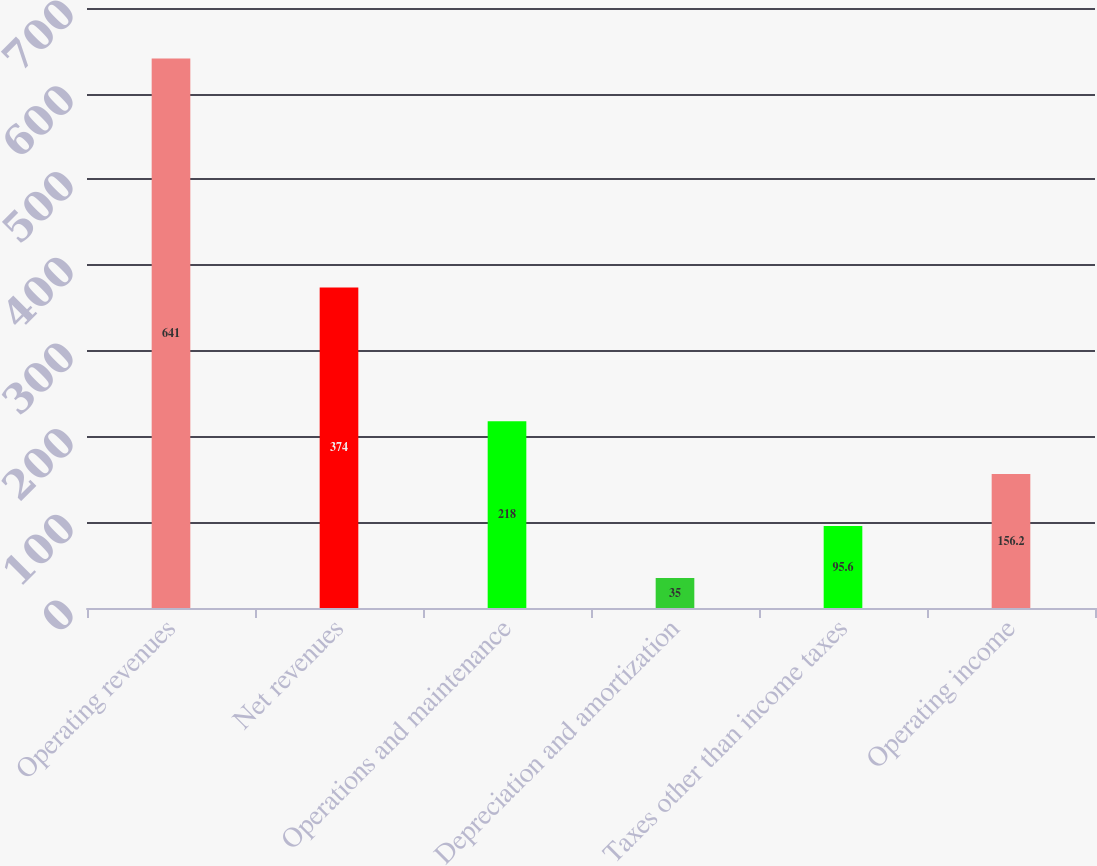Convert chart. <chart><loc_0><loc_0><loc_500><loc_500><bar_chart><fcel>Operating revenues<fcel>Net revenues<fcel>Operations and maintenance<fcel>Depreciation and amortization<fcel>Taxes other than income taxes<fcel>Operating income<nl><fcel>641<fcel>374<fcel>218<fcel>35<fcel>95.6<fcel>156.2<nl></chart> 